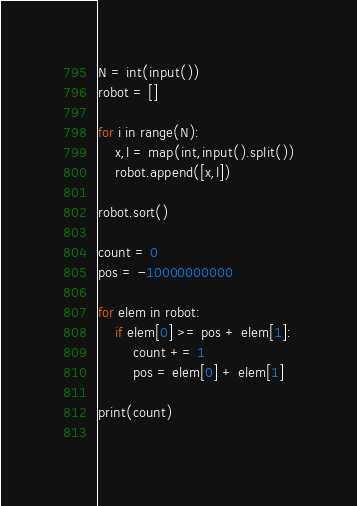<code> <loc_0><loc_0><loc_500><loc_500><_Python_>N = int(input())
robot = []

for i in range(N):
    x,l = map(int,input().split())
    robot.append([x,l])
    
robot.sort()

count = 0
pos = -10000000000

for elem in robot:
    if elem[0] >= pos + elem[1]:
        count += 1
        pos = elem[0] + elem[1]

print(count)
    </code> 